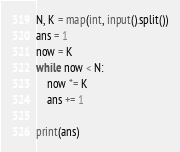Convert code to text. <code><loc_0><loc_0><loc_500><loc_500><_Python_>N, K = map(int, input().split())
ans = 1
now = K
while now < N:
    now *= K
    ans += 1

print(ans)</code> 